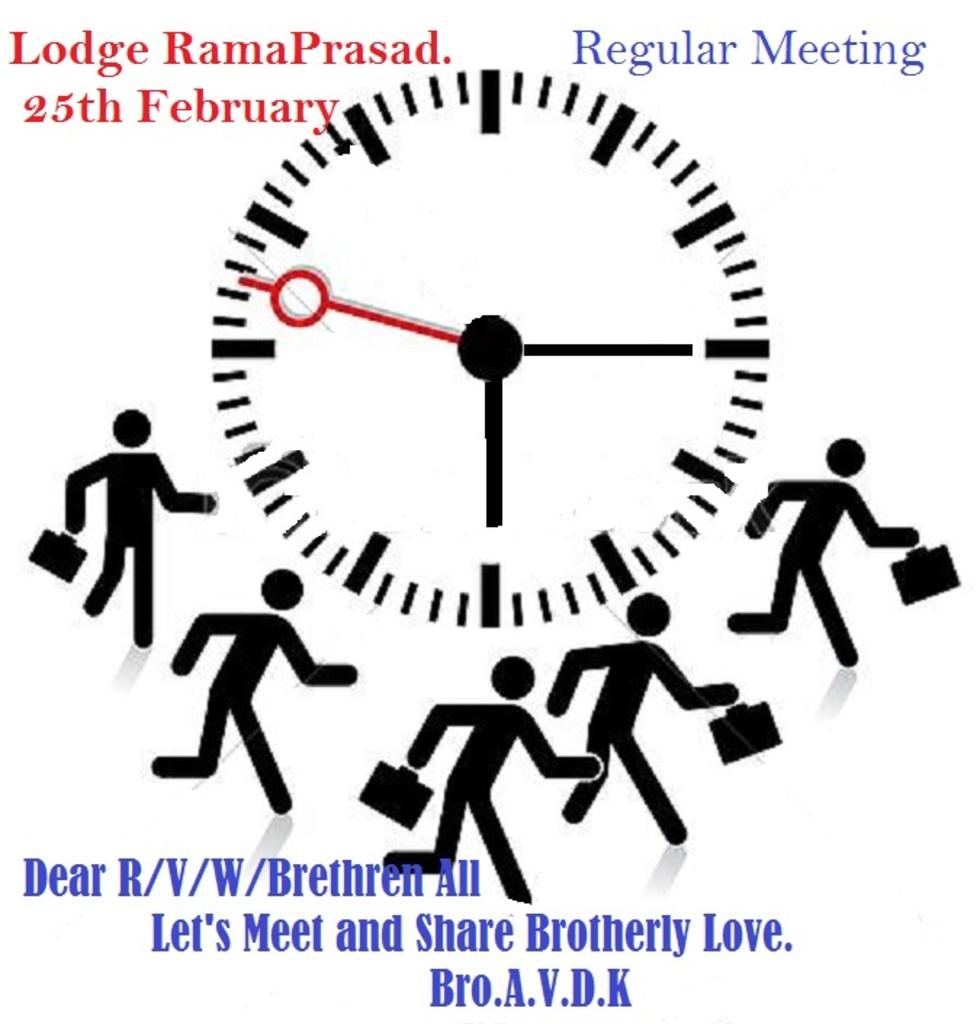<image>
Render a clear and concise summary of the photo. A flyer with a clock image and Regular Meeting at the top of it. 